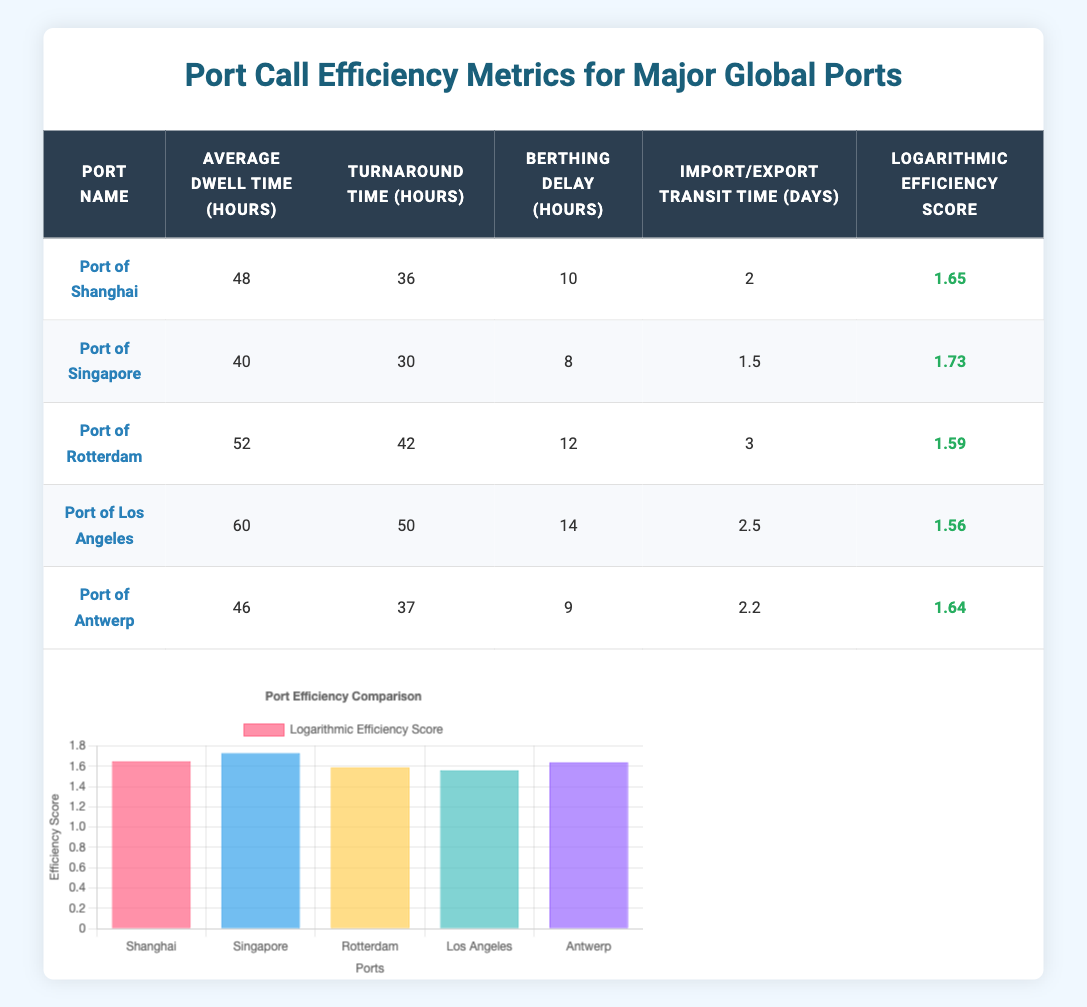What is the average dwell time for the Port of Singapore? The average dwell time for the Port of Singapore is directly given in the table under the "Average Dwell Time (hours)" column. It is listed as 40 hours.
Answer: 40 hours Which port has the highest logarithmic efficiency score? By examining the "Logarithmic Efficiency Score" column, the highest score is for the Port of Singapore, which has a score of 1.73.
Answer: Port of Singapore What is the turnaround time for the Port of Rotterdam? The turnaround time for the Port of Rotterdam is stated in the table under the "Turnaround Time (hours)" column, which is 42 hours.
Answer: 42 hours What is the average berthing delay across all ports? To find the average berthing delay, we sum the values in the "Berthing Delay (hours)" column (10 + 8 + 12 + 14 + 9 = 53) and then divide by the number of ports (5), giving an average of 53/5 = 10.6 hours.
Answer: 10.6 hours Is the import/export transit time for the Port of Los Angeles less than 3 days? The table shows the import/export transit time for the Port of Los Angeles as 2.5 days, which is indeed less than 3 days. Therefore, the answer is true.
Answer: Yes Which port has the longest average dwell time? Analyzing the "Average Dwell Time (hours)" column, the Port of Los Angeles has the longest dwell time at 60 hours.
Answer: Port of Los Angeles What is the average logarithmic efficiency score of the ports? To find the average logarithmic efficiency score, we sum all the scores (1.65 + 1.73 + 1.59 + 1.56 + 1.64 = 8.17) and divide by the number of ports (5), resulting in an average score of 8.17/5 = 1.634.
Answer: 1.634 Do all ports have a berthing delay of more than 8 hours? By checking the "Berthing Delay (hours)" column, we see that Port of Singapore has a berthing delay of 8 hours, so at least one port does not exceed this threshold.
Answer: No What is the difference in average dwell time between the Port of Shanghai and the Port of Antwerp? The average dwell time for the Port of Shanghai is 48 hours and for the Port of Antwerp is 46 hours. The difference between them is 48 - 46 = 2 hours.
Answer: 2 hours 